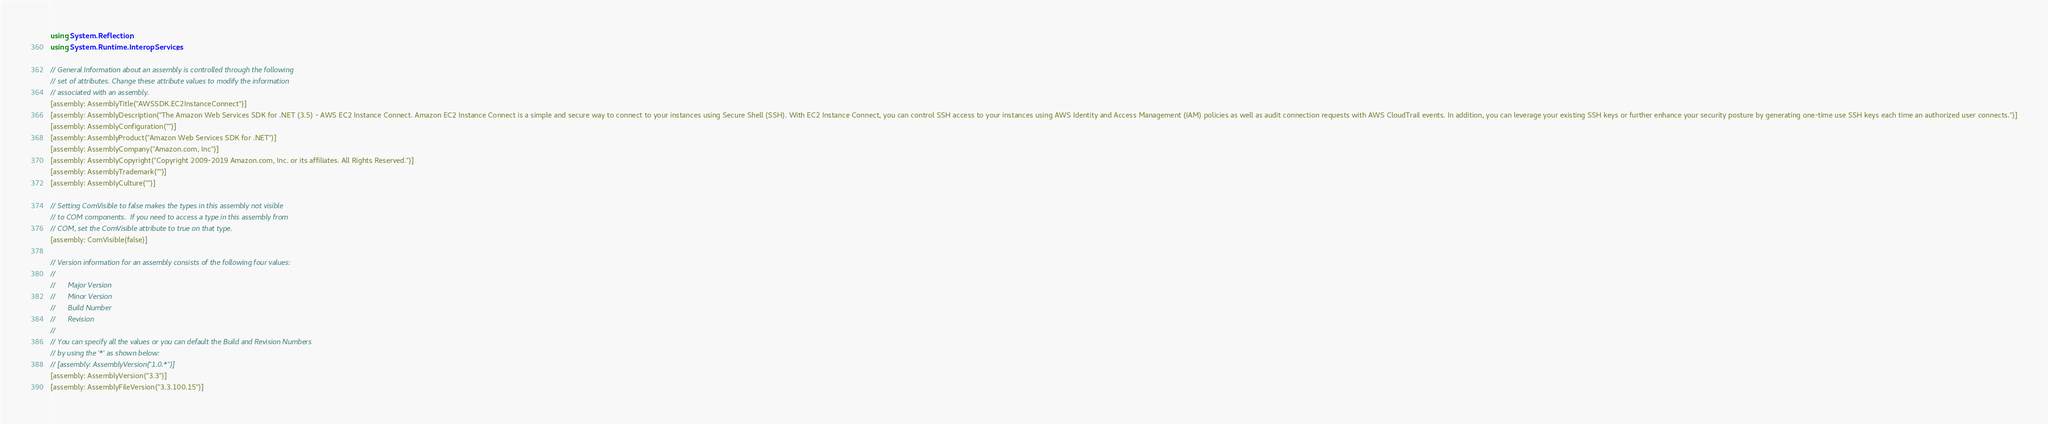<code> <loc_0><loc_0><loc_500><loc_500><_C#_>using System.Reflection;
using System.Runtime.InteropServices;

// General Information about an assembly is controlled through the following 
// set of attributes. Change these attribute values to modify the information
// associated with an assembly.
[assembly: AssemblyTitle("AWSSDK.EC2InstanceConnect")]
[assembly: AssemblyDescription("The Amazon Web Services SDK for .NET (3.5) - AWS EC2 Instance Connect. Amazon EC2 Instance Connect is a simple and secure way to connect to your instances using Secure Shell (SSH). With EC2 Instance Connect, you can control SSH access to your instances using AWS Identity and Access Management (IAM) policies as well as audit connection requests with AWS CloudTrail events. In addition, you can leverage your existing SSH keys or further enhance your security posture by generating one-time use SSH keys each time an authorized user connects.")]
[assembly: AssemblyConfiguration("")]
[assembly: AssemblyProduct("Amazon Web Services SDK for .NET")]
[assembly: AssemblyCompany("Amazon.com, Inc")]
[assembly: AssemblyCopyright("Copyright 2009-2019 Amazon.com, Inc. or its affiliates. All Rights Reserved.")]
[assembly: AssemblyTrademark("")]
[assembly: AssemblyCulture("")]

// Setting ComVisible to false makes the types in this assembly not visible 
// to COM components.  If you need to access a type in this assembly from 
// COM, set the ComVisible attribute to true on that type.
[assembly: ComVisible(false)]

// Version information for an assembly consists of the following four values:
//
//      Major Version
//      Minor Version 
//      Build Number
//      Revision
//
// You can specify all the values or you can default the Build and Revision Numbers 
// by using the '*' as shown below:
// [assembly: AssemblyVersion("1.0.*")]
[assembly: AssemblyVersion("3.3")]
[assembly: AssemblyFileVersion("3.3.100.15")]</code> 